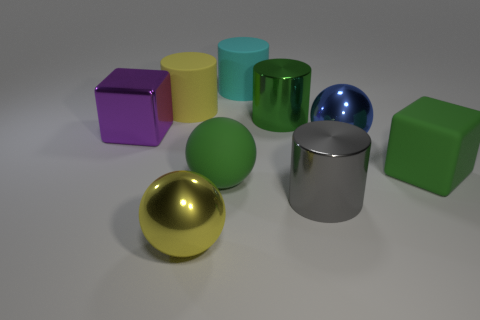Add 1 large balls. How many objects exist? 10 Subtract all blue cylinders. Subtract all brown spheres. How many cylinders are left? 4 Subtract all cylinders. How many objects are left? 5 Subtract all big purple objects. Subtract all large brown metallic balls. How many objects are left? 8 Add 5 large matte balls. How many large matte balls are left? 6 Add 1 gray metallic cylinders. How many gray metallic cylinders exist? 2 Subtract 0 cyan blocks. How many objects are left? 9 